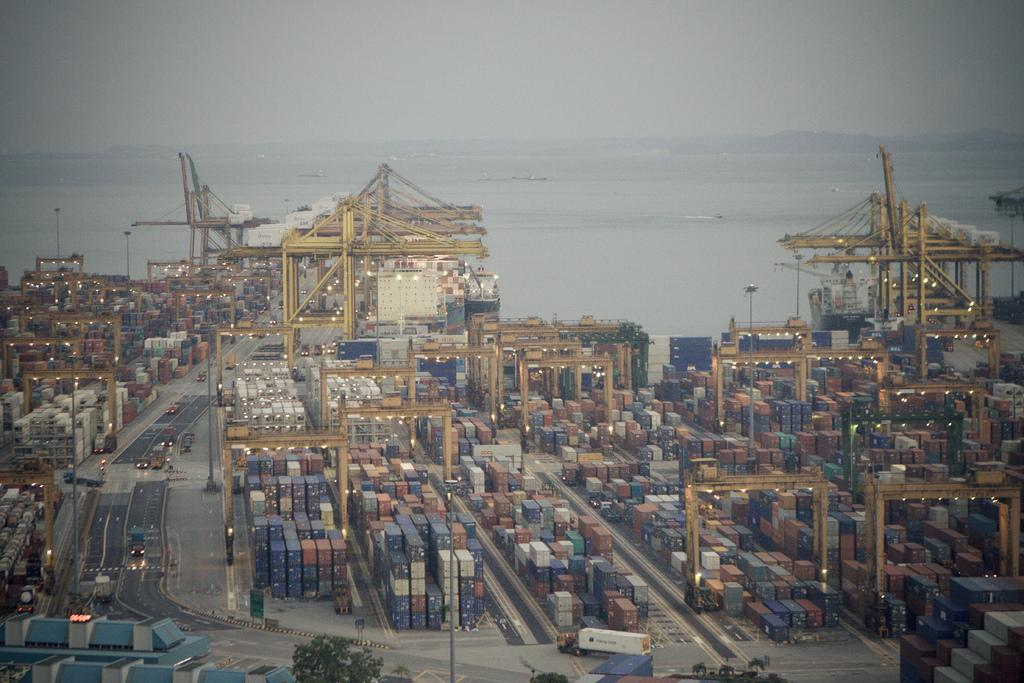What objects can be seen in the image? There are containers in the image. Where are the containers located? The containers are in a shipyard. What can be seen in the background of the image? There is an ocean visible in the background of the image. How many times did the containers change color during the rainstorm in the image? There is no rainstorm present in the image, and the containers do not change color. 